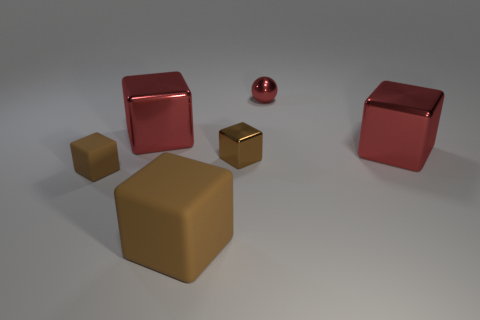Subtract all purple cylinders. How many brown blocks are left? 3 Subtract all large rubber cubes. How many cubes are left? 4 Subtract 3 blocks. How many blocks are left? 2 Subtract all gray cubes. Subtract all yellow spheres. How many cubes are left? 5 Add 3 small brown rubber things. How many objects exist? 9 Subtract all cubes. How many objects are left? 1 Add 2 red objects. How many red objects exist? 5 Subtract 2 red cubes. How many objects are left? 4 Subtract all big yellow matte objects. Subtract all big rubber things. How many objects are left? 5 Add 3 big matte objects. How many big matte objects are left? 4 